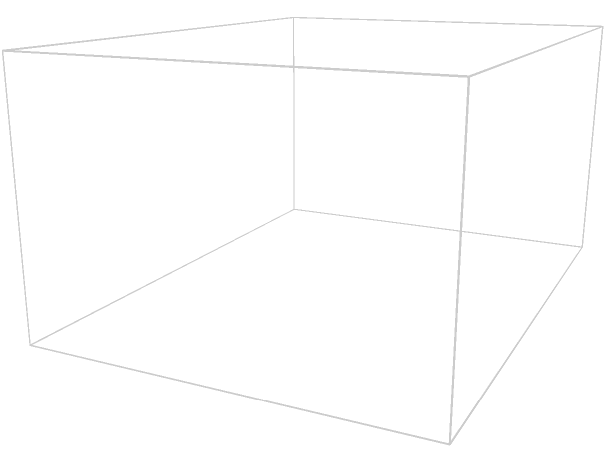Your new job requires you to pack spherical stress balls into rectangular boxes for a company event. The box measures 4 inches long, 3 inches wide, and 2 inches tall. If each stress ball has a diameter of 1 inch, how many whole stress balls can you fit inside one box? Let's break this down step-by-step:

1. Understand the dimensions:
   - Box: 4 inches × 3 inches × 2 inches
   - Stress ball diameter: 1 inch

2. Calculate how many balls can fit in each dimension:
   - Length: 4 ÷ 1 = 4 balls
   - Width: 3 ÷ 1 = 3 balls
   - Height: 2 ÷ 1 = 2 balls

3. Multiply these numbers together:
   $4 \times 3 \times 2 = 24$ balls

This is the maximum number of whole stress balls that can fit in the box if they were perfectly arranged.

4. Visualize the arrangement:
   - You can think of it as 4 rows, with 3 balls in each row, and 2 layers of this arrangement.

5. Double-check:
   - Count the balls in the image: 2 rows of 2 balls each, and there would be 2 layers of this arrangement.
   - $2 \times 2 \times 2 = 8$ balls visible in the image
   - The rest would be behind or on top of these visible balls.

Therefore, you can fit 24 whole stress balls in the box.
Answer: 24 stress balls 